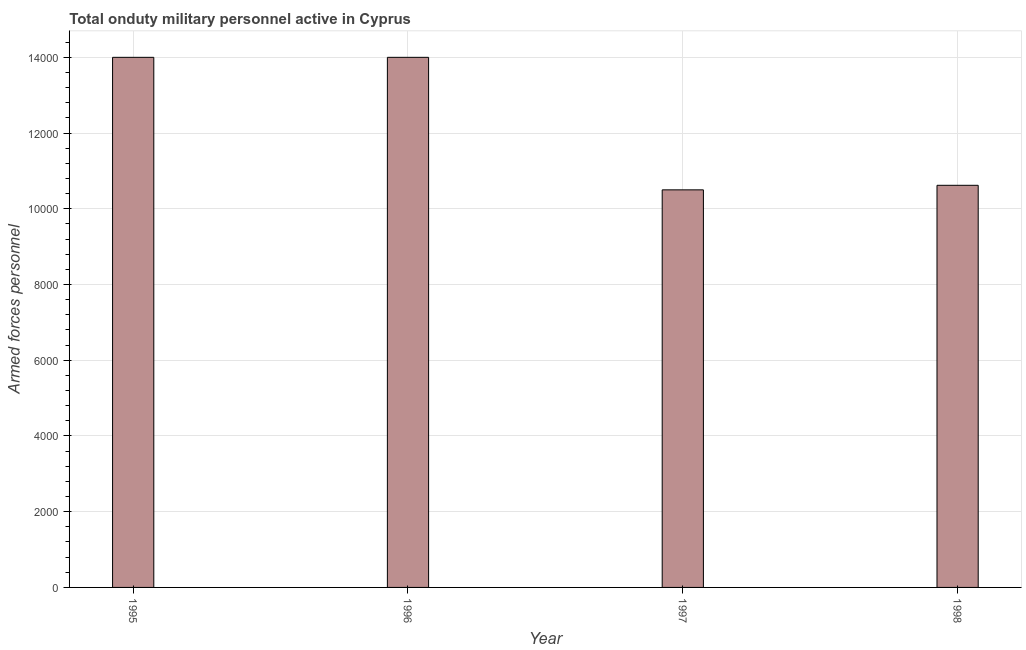Does the graph contain any zero values?
Ensure brevity in your answer.  No. Does the graph contain grids?
Offer a very short reply. Yes. What is the title of the graph?
Offer a very short reply. Total onduty military personnel active in Cyprus. What is the label or title of the X-axis?
Your answer should be compact. Year. What is the label or title of the Y-axis?
Offer a very short reply. Armed forces personnel. What is the number of armed forces personnel in 1995?
Your response must be concise. 1.40e+04. Across all years, what is the maximum number of armed forces personnel?
Make the answer very short. 1.40e+04. Across all years, what is the minimum number of armed forces personnel?
Provide a short and direct response. 1.05e+04. In which year was the number of armed forces personnel maximum?
Provide a succinct answer. 1995. In which year was the number of armed forces personnel minimum?
Offer a terse response. 1997. What is the sum of the number of armed forces personnel?
Your response must be concise. 4.91e+04. What is the difference between the number of armed forces personnel in 1996 and 1998?
Offer a very short reply. 3380. What is the average number of armed forces personnel per year?
Ensure brevity in your answer.  1.23e+04. What is the median number of armed forces personnel?
Give a very brief answer. 1.23e+04. What is the ratio of the number of armed forces personnel in 1996 to that in 1998?
Give a very brief answer. 1.32. Is the number of armed forces personnel in 1996 less than that in 1998?
Keep it short and to the point. No. Is the difference between the number of armed forces personnel in 1995 and 1997 greater than the difference between any two years?
Give a very brief answer. Yes. What is the difference between the highest and the second highest number of armed forces personnel?
Offer a terse response. 0. What is the difference between the highest and the lowest number of armed forces personnel?
Keep it short and to the point. 3500. In how many years, is the number of armed forces personnel greater than the average number of armed forces personnel taken over all years?
Provide a succinct answer. 2. How many years are there in the graph?
Make the answer very short. 4. Are the values on the major ticks of Y-axis written in scientific E-notation?
Give a very brief answer. No. What is the Armed forces personnel in 1995?
Offer a terse response. 1.40e+04. What is the Armed forces personnel of 1996?
Your response must be concise. 1.40e+04. What is the Armed forces personnel of 1997?
Your response must be concise. 1.05e+04. What is the Armed forces personnel in 1998?
Make the answer very short. 1.06e+04. What is the difference between the Armed forces personnel in 1995 and 1997?
Provide a short and direct response. 3500. What is the difference between the Armed forces personnel in 1995 and 1998?
Ensure brevity in your answer.  3380. What is the difference between the Armed forces personnel in 1996 and 1997?
Ensure brevity in your answer.  3500. What is the difference between the Armed forces personnel in 1996 and 1998?
Offer a very short reply. 3380. What is the difference between the Armed forces personnel in 1997 and 1998?
Your response must be concise. -120. What is the ratio of the Armed forces personnel in 1995 to that in 1996?
Give a very brief answer. 1. What is the ratio of the Armed forces personnel in 1995 to that in 1997?
Make the answer very short. 1.33. What is the ratio of the Armed forces personnel in 1995 to that in 1998?
Your answer should be compact. 1.32. What is the ratio of the Armed forces personnel in 1996 to that in 1997?
Keep it short and to the point. 1.33. What is the ratio of the Armed forces personnel in 1996 to that in 1998?
Your answer should be compact. 1.32. What is the ratio of the Armed forces personnel in 1997 to that in 1998?
Your response must be concise. 0.99. 